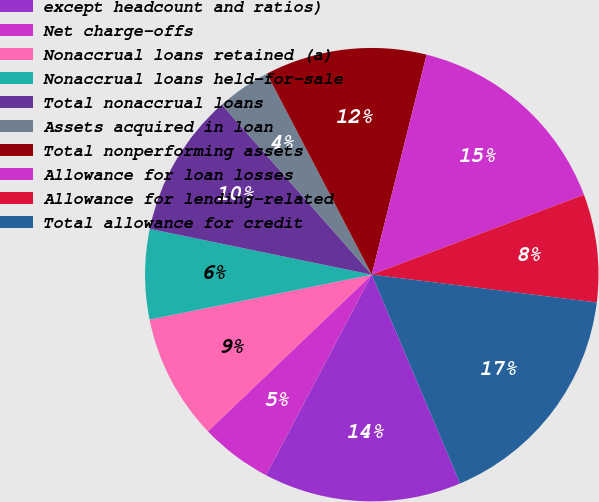Convert chart to OTSL. <chart><loc_0><loc_0><loc_500><loc_500><pie_chart><fcel>except headcount and ratios)<fcel>Net charge-offs<fcel>Nonaccrual loans retained (a)<fcel>Nonaccrual loans held-for-sale<fcel>Total nonaccrual loans<fcel>Assets acquired in loan<fcel>Total nonperforming assets<fcel>Allowance for loan losses<fcel>Allowance for lending-related<fcel>Total allowance for credit<nl><fcel>14.1%<fcel>5.13%<fcel>8.97%<fcel>6.41%<fcel>10.26%<fcel>3.85%<fcel>11.54%<fcel>15.38%<fcel>7.69%<fcel>16.67%<nl></chart> 